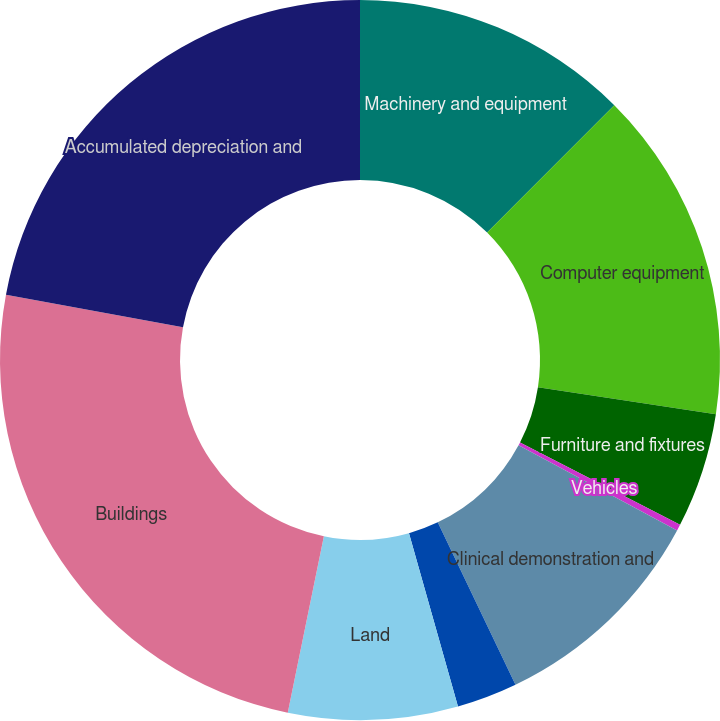Convert chart. <chart><loc_0><loc_0><loc_500><loc_500><pie_chart><fcel>Machinery and equipment<fcel>Computer equipment<fcel>Furniture and fixtures<fcel>Vehicles<fcel>Clinical demonstration and<fcel>Leasehold improvements<fcel>Land<fcel>Buildings<fcel>Accumulated depreciation and<nl><fcel>12.48%<fcel>14.92%<fcel>5.16%<fcel>0.28%<fcel>10.04%<fcel>2.72%<fcel>7.6%<fcel>24.68%<fcel>22.09%<nl></chart> 